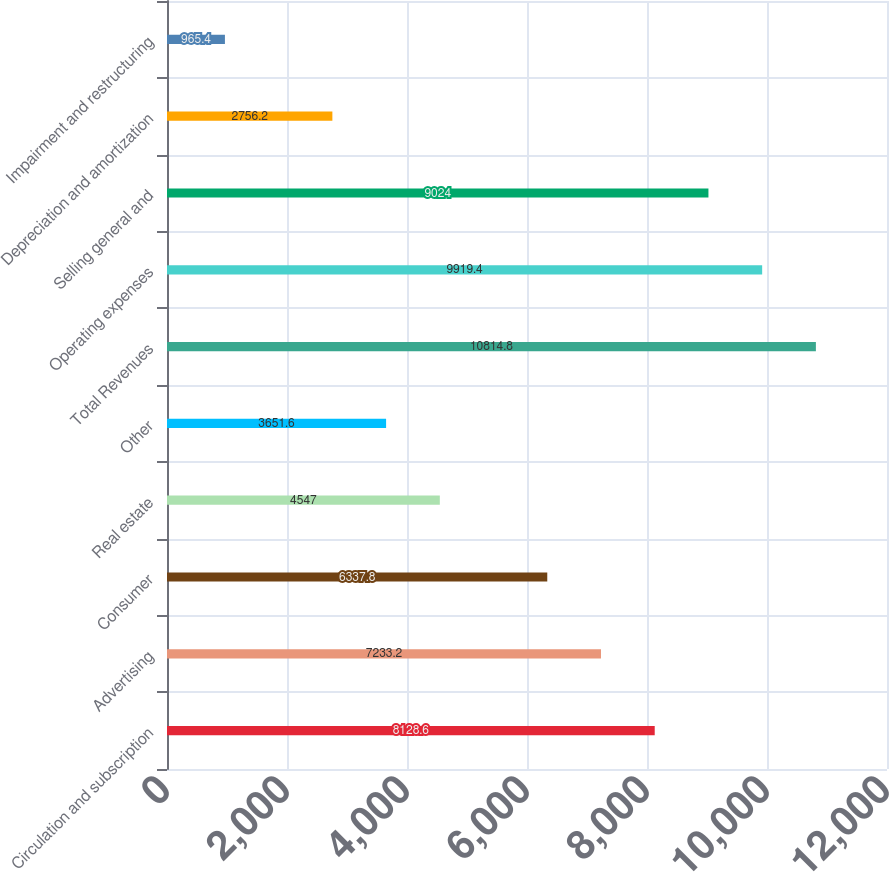<chart> <loc_0><loc_0><loc_500><loc_500><bar_chart><fcel>Circulation and subscription<fcel>Advertising<fcel>Consumer<fcel>Real estate<fcel>Other<fcel>Total Revenues<fcel>Operating expenses<fcel>Selling general and<fcel>Depreciation and amortization<fcel>Impairment and restructuring<nl><fcel>8128.6<fcel>7233.2<fcel>6337.8<fcel>4547<fcel>3651.6<fcel>10814.8<fcel>9919.4<fcel>9024<fcel>2756.2<fcel>965.4<nl></chart> 